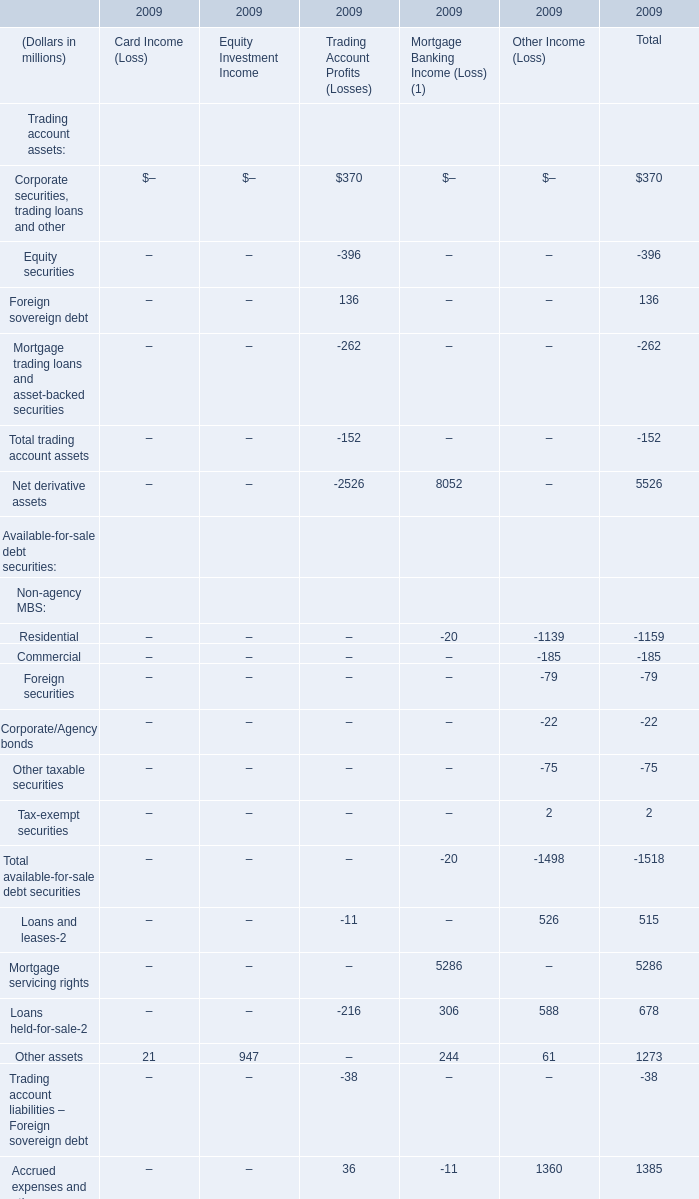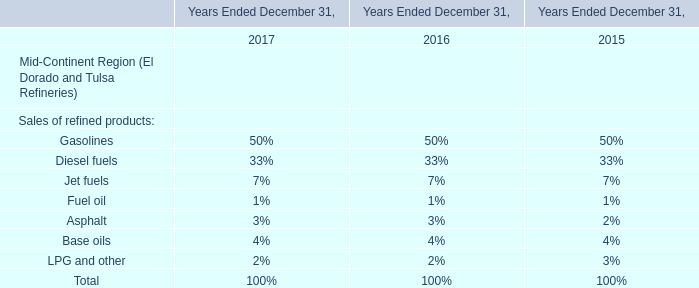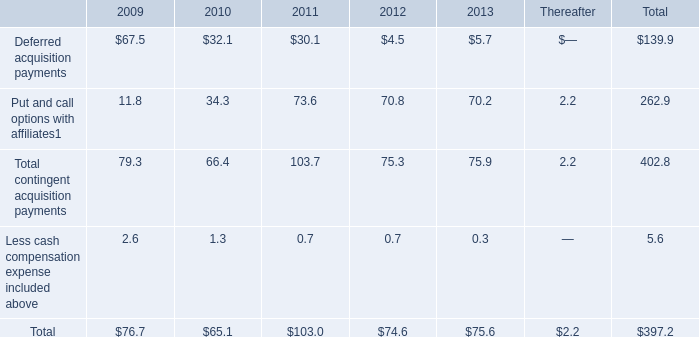What's the increasing rate of Total of Card Income (Loss) in 2009? 
Computations: ((21 - 55) / 55)
Answer: -0.61818. 